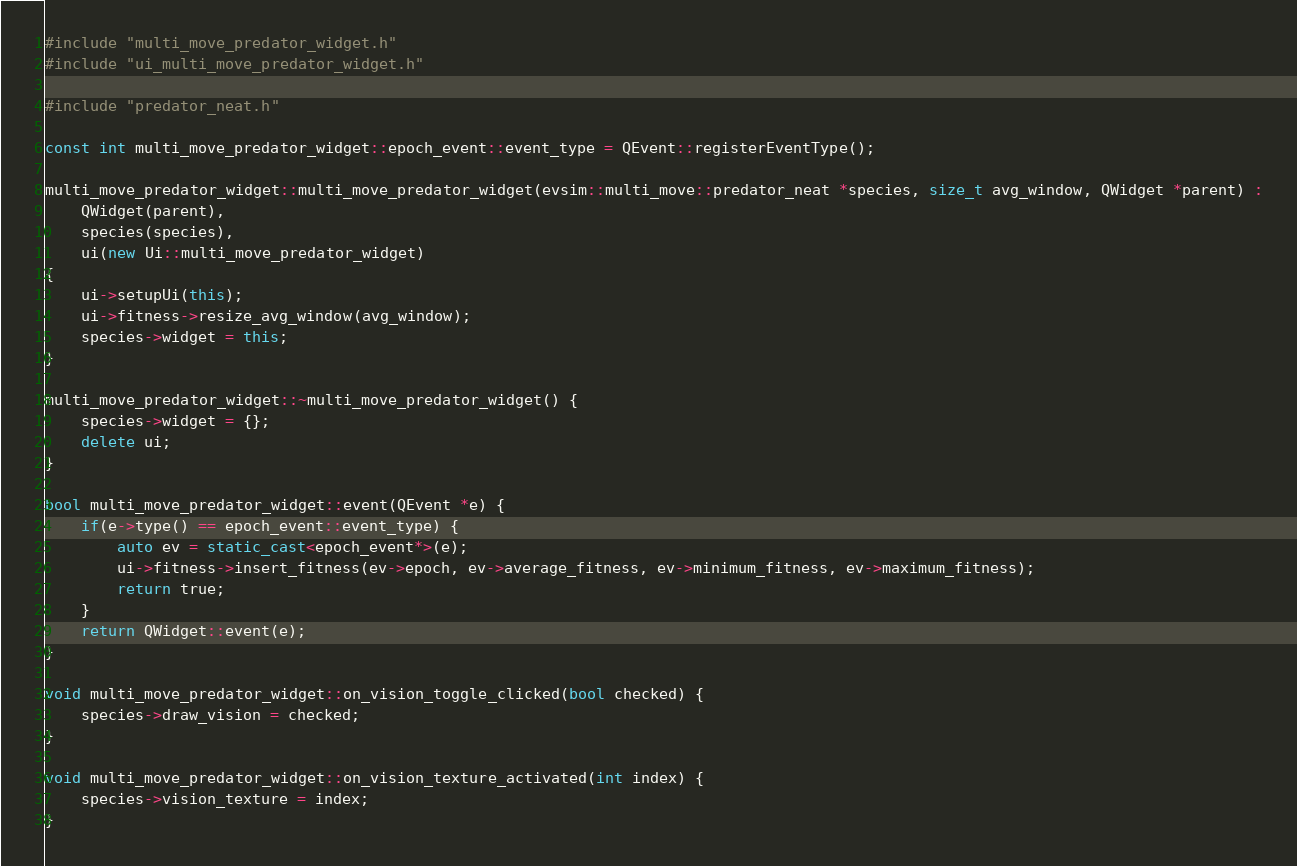<code> <loc_0><loc_0><loc_500><loc_500><_C++_>#include "multi_move_predator_widget.h"
#include "ui_multi_move_predator_widget.h"

#include "predator_neat.h"

const int multi_move_predator_widget::epoch_event::event_type = QEvent::registerEventType();

multi_move_predator_widget::multi_move_predator_widget(evsim::multi_move::predator_neat *species, size_t avg_window, QWidget *parent) :
    QWidget(parent),
	species(species),
	ui(new Ui::multi_move_predator_widget)
{
    ui->setupUi(this);
	ui->fitness->resize_avg_window(avg_window);
	species->widget = this;
}

multi_move_predator_widget::~multi_move_predator_widget() {
	species->widget = {};
    delete ui;
}

bool multi_move_predator_widget::event(QEvent *e) {
	if(e->type() == epoch_event::event_type) {
		auto ev = static_cast<epoch_event*>(e);
		ui->fitness->insert_fitness(ev->epoch, ev->average_fitness, ev->minimum_fitness, ev->maximum_fitness);
		return true;
	}
	return QWidget::event(e);
}

void multi_move_predator_widget::on_vision_toggle_clicked(bool checked) {
	species->draw_vision = checked;
}

void multi_move_predator_widget::on_vision_texture_activated(int index) {
	species->vision_texture = index;
}
</code> 